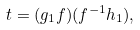Convert formula to latex. <formula><loc_0><loc_0><loc_500><loc_500>t = ( g _ { 1 } f ) ( f ^ { - 1 } h _ { 1 } ) ,</formula> 